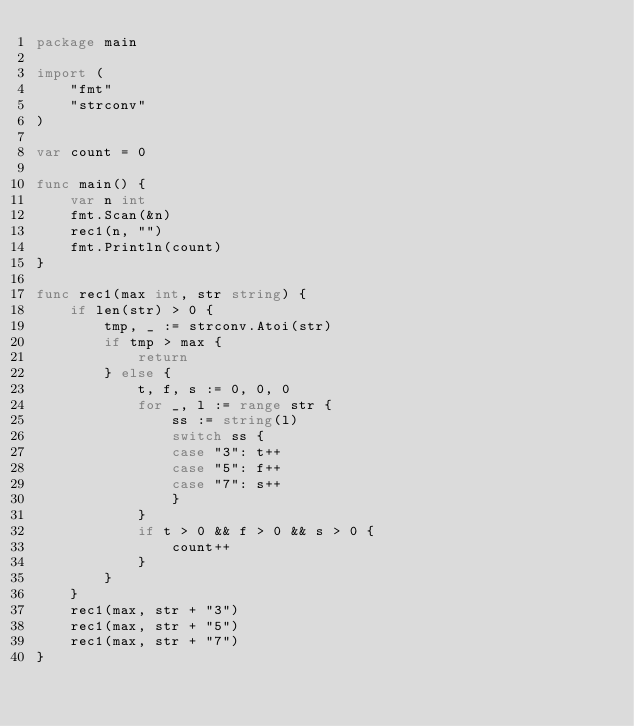Convert code to text. <code><loc_0><loc_0><loc_500><loc_500><_Go_>package main

import (
	"fmt"
	"strconv"
)

var count = 0

func main() {
	var n int
	fmt.Scan(&n)
	rec1(n, "")
	fmt.Println(count)
}

func rec1(max int, str string) {
	if len(str) > 0 {
		tmp, _ := strconv.Atoi(str)
		if tmp > max {
			return
		} else {
			t, f, s := 0, 0, 0
			for _, l := range str {
				ss := string(l)
				switch ss {
				case "3": t++
				case "5": f++
				case "7": s++
				}
			}
			if t > 0 && f > 0 && s > 0 {
				count++
			}
		}
	}
	rec1(max, str + "3")
	rec1(max, str + "5")
	rec1(max, str + "7")
}</code> 